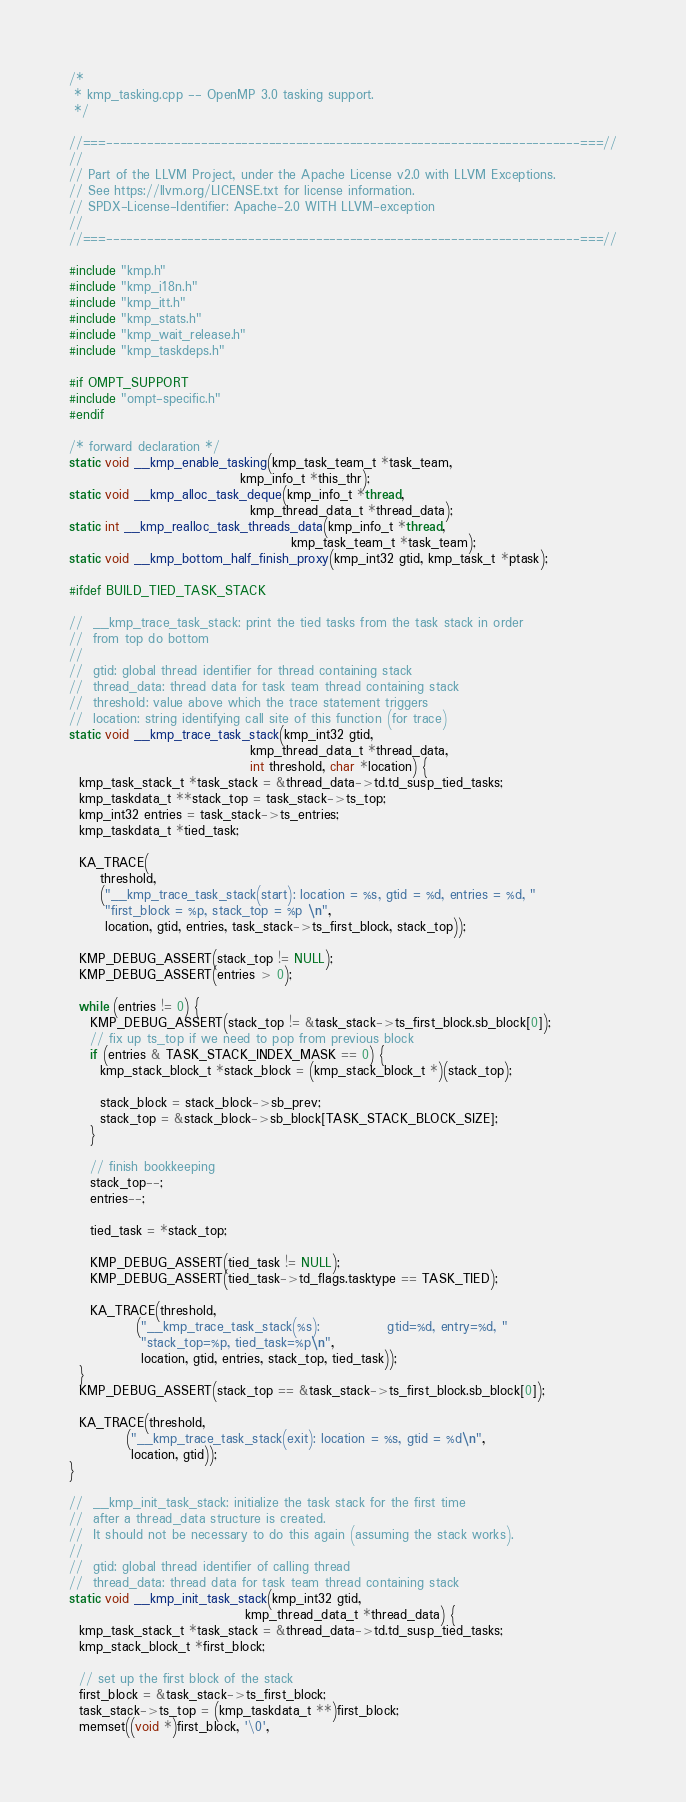<code> <loc_0><loc_0><loc_500><loc_500><_C++_>/*
 * kmp_tasking.cpp -- OpenMP 3.0 tasking support.
 */

//===----------------------------------------------------------------------===//
//
// Part of the LLVM Project, under the Apache License v2.0 with LLVM Exceptions.
// See https://llvm.org/LICENSE.txt for license information.
// SPDX-License-Identifier: Apache-2.0 WITH LLVM-exception
//
//===----------------------------------------------------------------------===//

#include "kmp.h"
#include "kmp_i18n.h"
#include "kmp_itt.h"
#include "kmp_stats.h"
#include "kmp_wait_release.h"
#include "kmp_taskdeps.h"

#if OMPT_SUPPORT
#include "ompt-specific.h"
#endif

/* forward declaration */
static void __kmp_enable_tasking(kmp_task_team_t *task_team,
                                 kmp_info_t *this_thr);
static void __kmp_alloc_task_deque(kmp_info_t *thread,
                                   kmp_thread_data_t *thread_data);
static int __kmp_realloc_task_threads_data(kmp_info_t *thread,
                                           kmp_task_team_t *task_team);
static void __kmp_bottom_half_finish_proxy(kmp_int32 gtid, kmp_task_t *ptask);

#ifdef BUILD_TIED_TASK_STACK

//  __kmp_trace_task_stack: print the tied tasks from the task stack in order
//  from top do bottom
//
//  gtid: global thread identifier for thread containing stack
//  thread_data: thread data for task team thread containing stack
//  threshold: value above which the trace statement triggers
//  location: string identifying call site of this function (for trace)
static void __kmp_trace_task_stack(kmp_int32 gtid,
                                   kmp_thread_data_t *thread_data,
                                   int threshold, char *location) {
  kmp_task_stack_t *task_stack = &thread_data->td.td_susp_tied_tasks;
  kmp_taskdata_t **stack_top = task_stack->ts_top;
  kmp_int32 entries = task_stack->ts_entries;
  kmp_taskdata_t *tied_task;

  KA_TRACE(
      threshold,
      ("__kmp_trace_task_stack(start): location = %s, gtid = %d, entries = %d, "
       "first_block = %p, stack_top = %p \n",
       location, gtid, entries, task_stack->ts_first_block, stack_top));

  KMP_DEBUG_ASSERT(stack_top != NULL);
  KMP_DEBUG_ASSERT(entries > 0);

  while (entries != 0) {
    KMP_DEBUG_ASSERT(stack_top != &task_stack->ts_first_block.sb_block[0]);
    // fix up ts_top if we need to pop from previous block
    if (entries & TASK_STACK_INDEX_MASK == 0) {
      kmp_stack_block_t *stack_block = (kmp_stack_block_t *)(stack_top);

      stack_block = stack_block->sb_prev;
      stack_top = &stack_block->sb_block[TASK_STACK_BLOCK_SIZE];
    }

    // finish bookkeeping
    stack_top--;
    entries--;

    tied_task = *stack_top;

    KMP_DEBUG_ASSERT(tied_task != NULL);
    KMP_DEBUG_ASSERT(tied_task->td_flags.tasktype == TASK_TIED);

    KA_TRACE(threshold,
             ("__kmp_trace_task_stack(%s):             gtid=%d, entry=%d, "
              "stack_top=%p, tied_task=%p\n",
              location, gtid, entries, stack_top, tied_task));
  }
  KMP_DEBUG_ASSERT(stack_top == &task_stack->ts_first_block.sb_block[0]);

  KA_TRACE(threshold,
           ("__kmp_trace_task_stack(exit): location = %s, gtid = %d\n",
            location, gtid));
}

//  __kmp_init_task_stack: initialize the task stack for the first time
//  after a thread_data structure is created.
//  It should not be necessary to do this again (assuming the stack works).
//
//  gtid: global thread identifier of calling thread
//  thread_data: thread data for task team thread containing stack
static void __kmp_init_task_stack(kmp_int32 gtid,
                                  kmp_thread_data_t *thread_data) {
  kmp_task_stack_t *task_stack = &thread_data->td.td_susp_tied_tasks;
  kmp_stack_block_t *first_block;

  // set up the first block of the stack
  first_block = &task_stack->ts_first_block;
  task_stack->ts_top = (kmp_taskdata_t **)first_block;
  memset((void *)first_block, '\0',</code> 